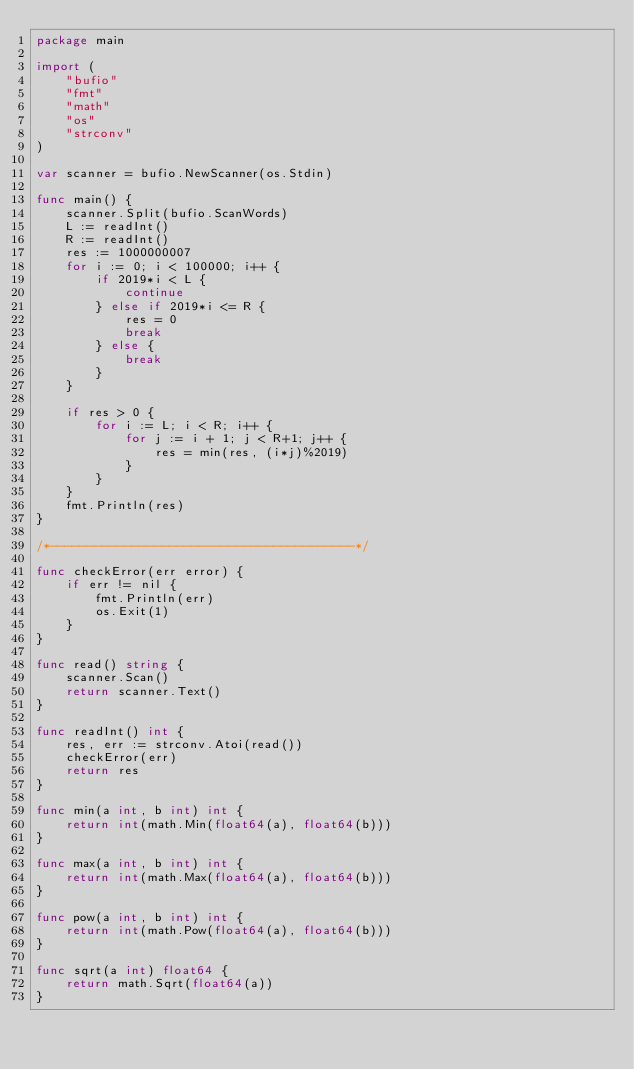<code> <loc_0><loc_0><loc_500><loc_500><_Go_>package main

import (
	"bufio"
	"fmt"
	"math"
	"os"
	"strconv"
)

var scanner = bufio.NewScanner(os.Stdin)

func main() {
	scanner.Split(bufio.ScanWords)
	L := readInt()
	R := readInt()
	res := 1000000007
	for i := 0; i < 100000; i++ {
		if 2019*i < L {
			continue
		} else if 2019*i <= R {
			res = 0
			break
		} else {
			break
		}
	}

	if res > 0 {
		for i := L; i < R; i++ {
			for j := i + 1; j < R+1; j++ {
				res = min(res, (i*j)%2019)
			}
		}
	}
	fmt.Println(res)
}

/*-----------------------------------------*/

func checkError(err error) {
	if err != nil {
		fmt.Println(err)
		os.Exit(1)
	}
}

func read() string {
	scanner.Scan()
	return scanner.Text()
}

func readInt() int {
	res, err := strconv.Atoi(read())
	checkError(err)
	return res
}

func min(a int, b int) int {
	return int(math.Min(float64(a), float64(b)))
}

func max(a int, b int) int {
	return int(math.Max(float64(a), float64(b)))
}

func pow(a int, b int) int {
	return int(math.Pow(float64(a), float64(b)))
}

func sqrt(a int) float64 {
	return math.Sqrt(float64(a))
}
</code> 